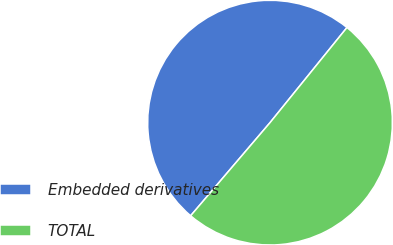Convert chart to OTSL. <chart><loc_0><loc_0><loc_500><loc_500><pie_chart><fcel>Embedded derivatives<fcel>TOTAL<nl><fcel>49.59%<fcel>50.41%<nl></chart> 